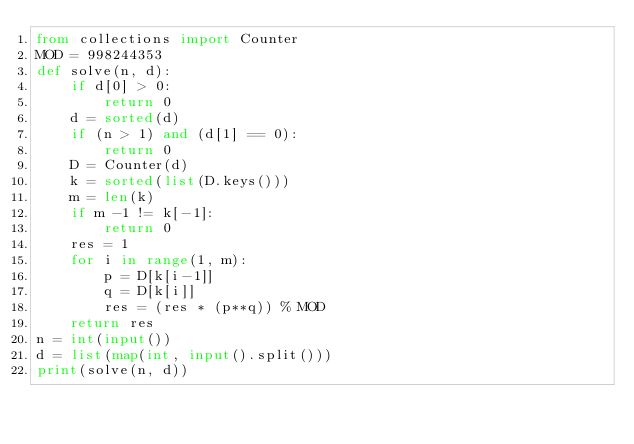Convert code to text. <code><loc_0><loc_0><loc_500><loc_500><_Python_>from collections import Counter
MOD = 998244353
def solve(n, d):
    if d[0] > 0:
        return 0
    d = sorted(d)  
    if (n > 1) and (d[1] == 0):
        return 0
    D = Counter(d) 
    k = sorted(list(D.keys()))
    m = len(k)  
    if m -1 != k[-1]:
        return 0
    res = 1
    for i in range(1, m):
        p = D[k[i-1]]
        q = D[k[i]]
        res = (res * (p**q)) % MOD
    return res
n = int(input())
d = list(map(int, input().split()))
print(solve(n, d))

</code> 